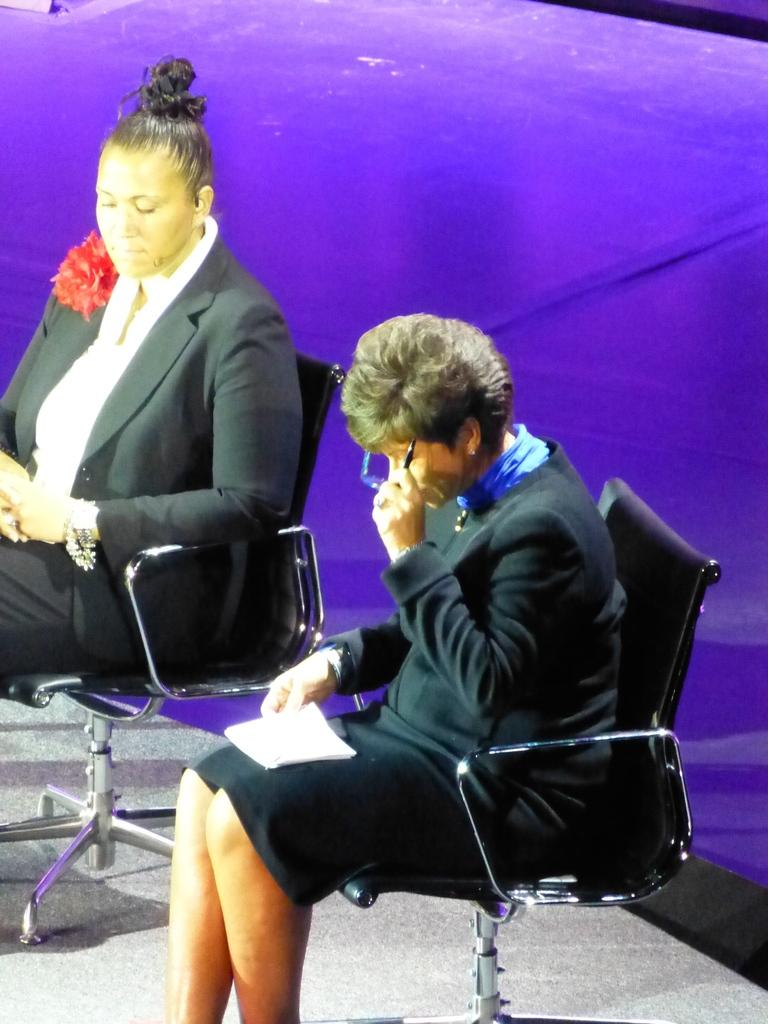How many people are in the image? There are two people in the image. What are the people doing in the image? The two people are sitting on chairs. What type of clothing are the people wearing? The people are wearing blazers. Is there a river visible in the image? No, there is no river present in the image. Are the two people in the image engaged in a fight? No, the two people are sitting on chairs and not engaged in a fight. 